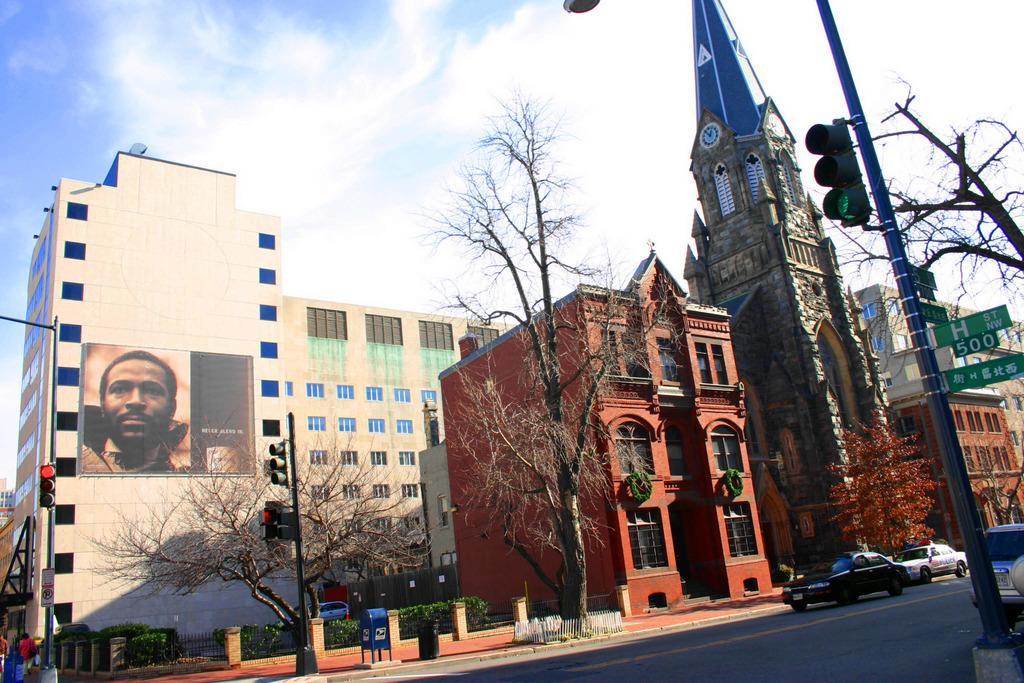Could you give a brief overview of what you see in this image? In this image I can see few building in cream and brown color. I can also see a clock tower, in front I can see few dried trees, traffic signals, few vehicles on the road. Background I can see sky in blue and white color. 